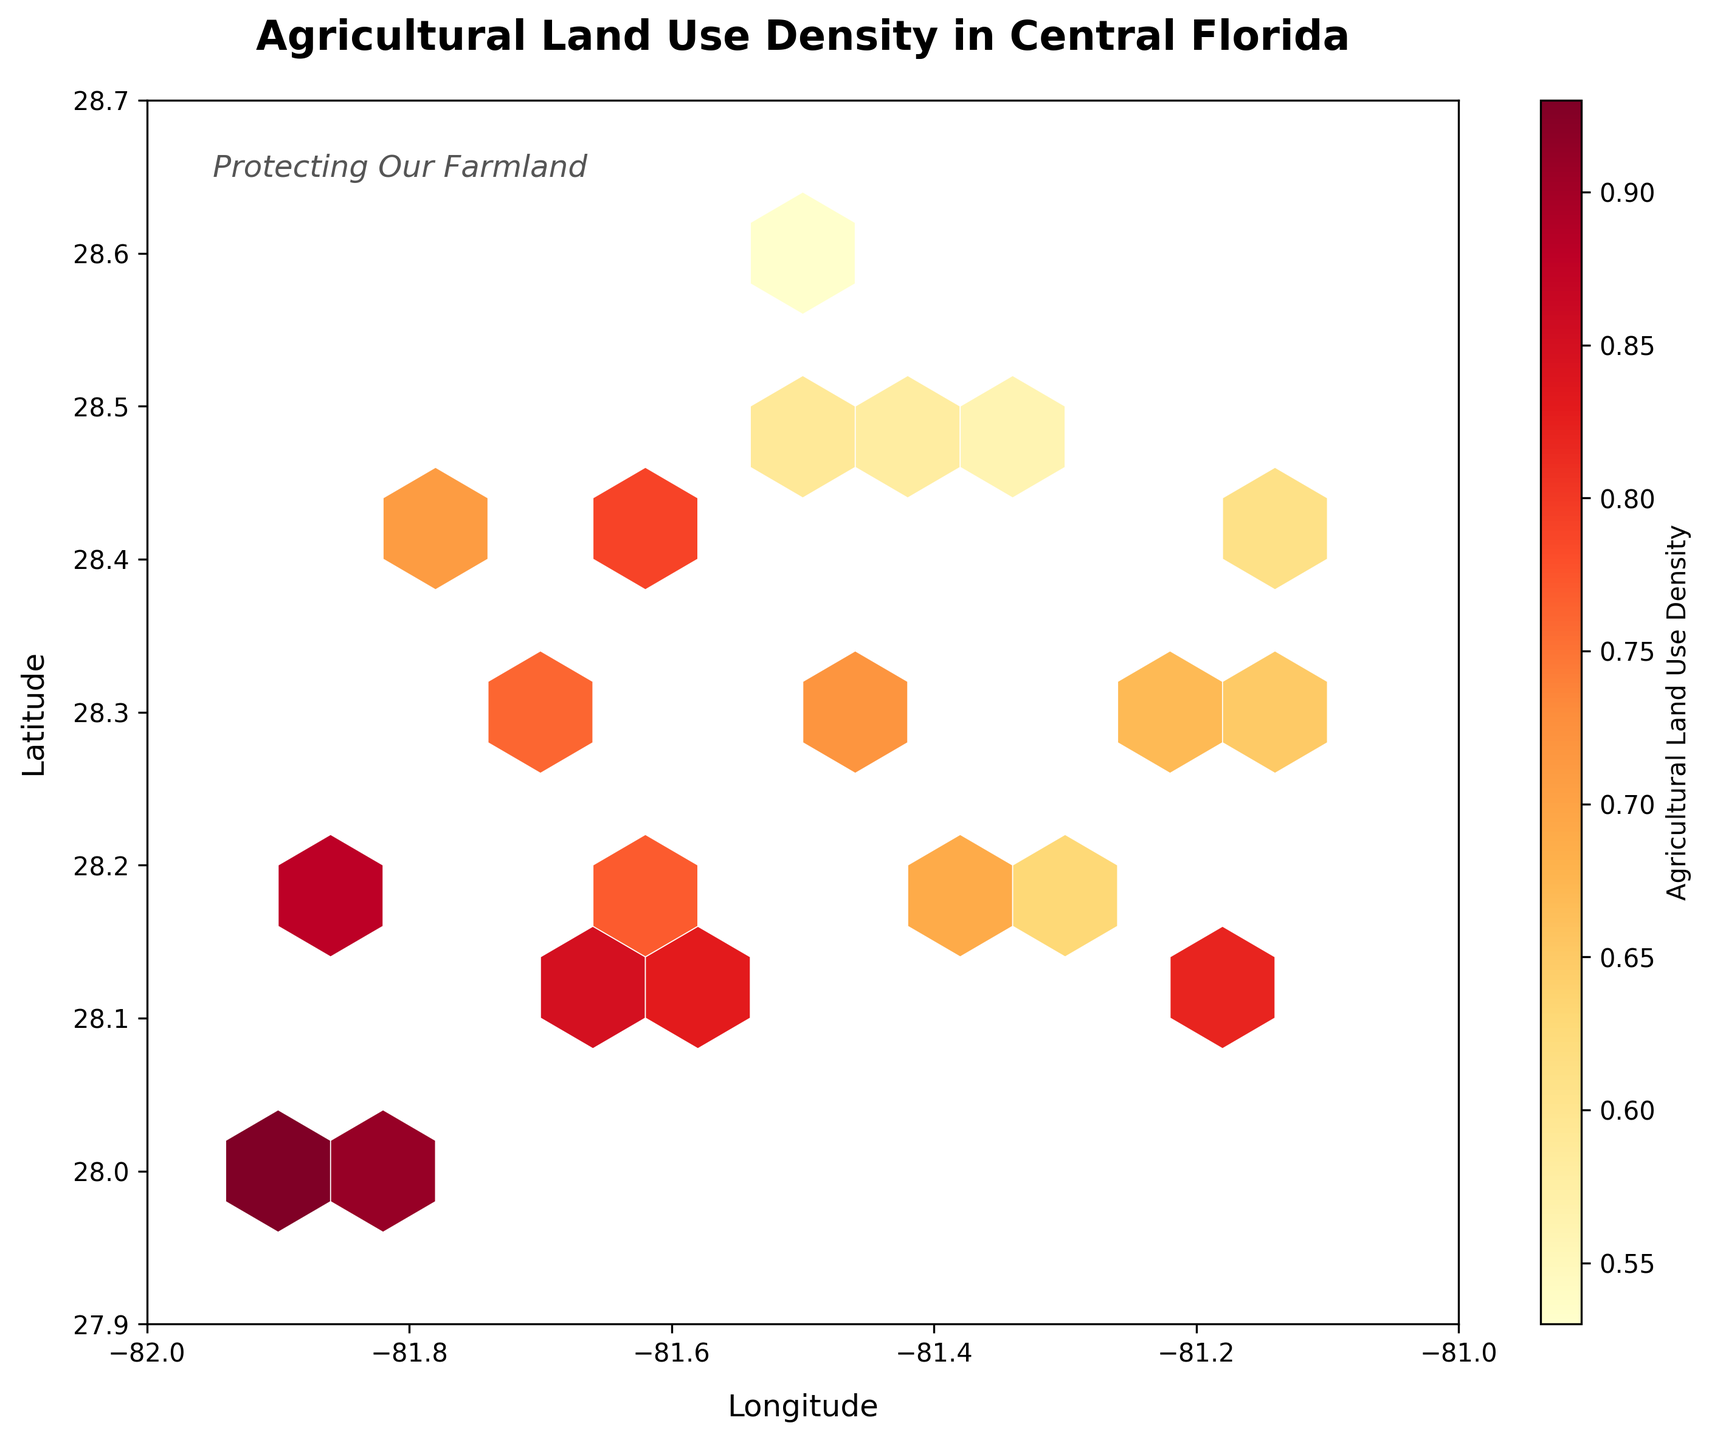What is the title of the plot? The title of the plot is written at the top center and is in bold. It reads 'Agricultural Land Use Density in Central Florida'.
Answer: Agricultural Land Use Density in Central Florida What does the colorbar represent? The colorbar displays the range of colors used in the hexbin plot, indicating the density of agricultural land use. The label 'Agricultural Land Use Density' is provided along with a color gradient from lighter to darker colors.
Answer: Agricultural Land Use Density What are the ranges of the x-axis and y-axis? The plot shows that the x-axis (Longitude) ranges from -82 to -81, and the y-axis (Latitude) ranges from 27.9 to 28.7. These ranges are set by the axis limits.
Answer: x: -82 to -81, y: 27.9 to 28.7 Where is the text 'Protecting Our Farmland' located on the plot? The text 'Protecting Our Farmland' is located near the top left of the plot, around the coordinates (-81.95, 28.65).
Answer: Near the top left Which area has the highest density of agricultural land use? The area near coordinates (-81.9, 28.0) has the highest density, as shown by the darkest color in the plot. The hexbin grid with the highest density value corresponds to the darkest color in the colorbar.
Answer: Near -81.9, 28.0 Is there a noticeable higher density region around central coordinates (-81.5, 28.3)? Comparing the densities near (-81.5, 28.3) to other areas, this region shows moderately high density with slightly lighter colors but not the highest.
Answer: Moderately high density Are there any regions with relatively low agricultural land use density? The plot shows regions with lighter colors, indicating lower density, around coordinates such as -81.4, 28.5, and -81.5, 28.6. These areas are represented by the lightest colors on the plot.
Answer: Around -81.4, 28.5 and -81.5, 28.6 Which coordinate pair has agricultural land use density above 0.85 but less than 0.9? By checking the color representing density against the colorbar, the coordinate pair (-81.7, 28.1) fits within this density range.
Answer: (-81.7, 28.1) What is the average agricultural land use density near coordinates (-81.5, 28.3)? By examining the plot hexbin around (-81.5, 28.3), which shows moderate density values, the average value appears slightly above mid-scale from the colorbar. A more detailed inspection of the data points could give a precise value.
Answer: Slightly above mid-scale 